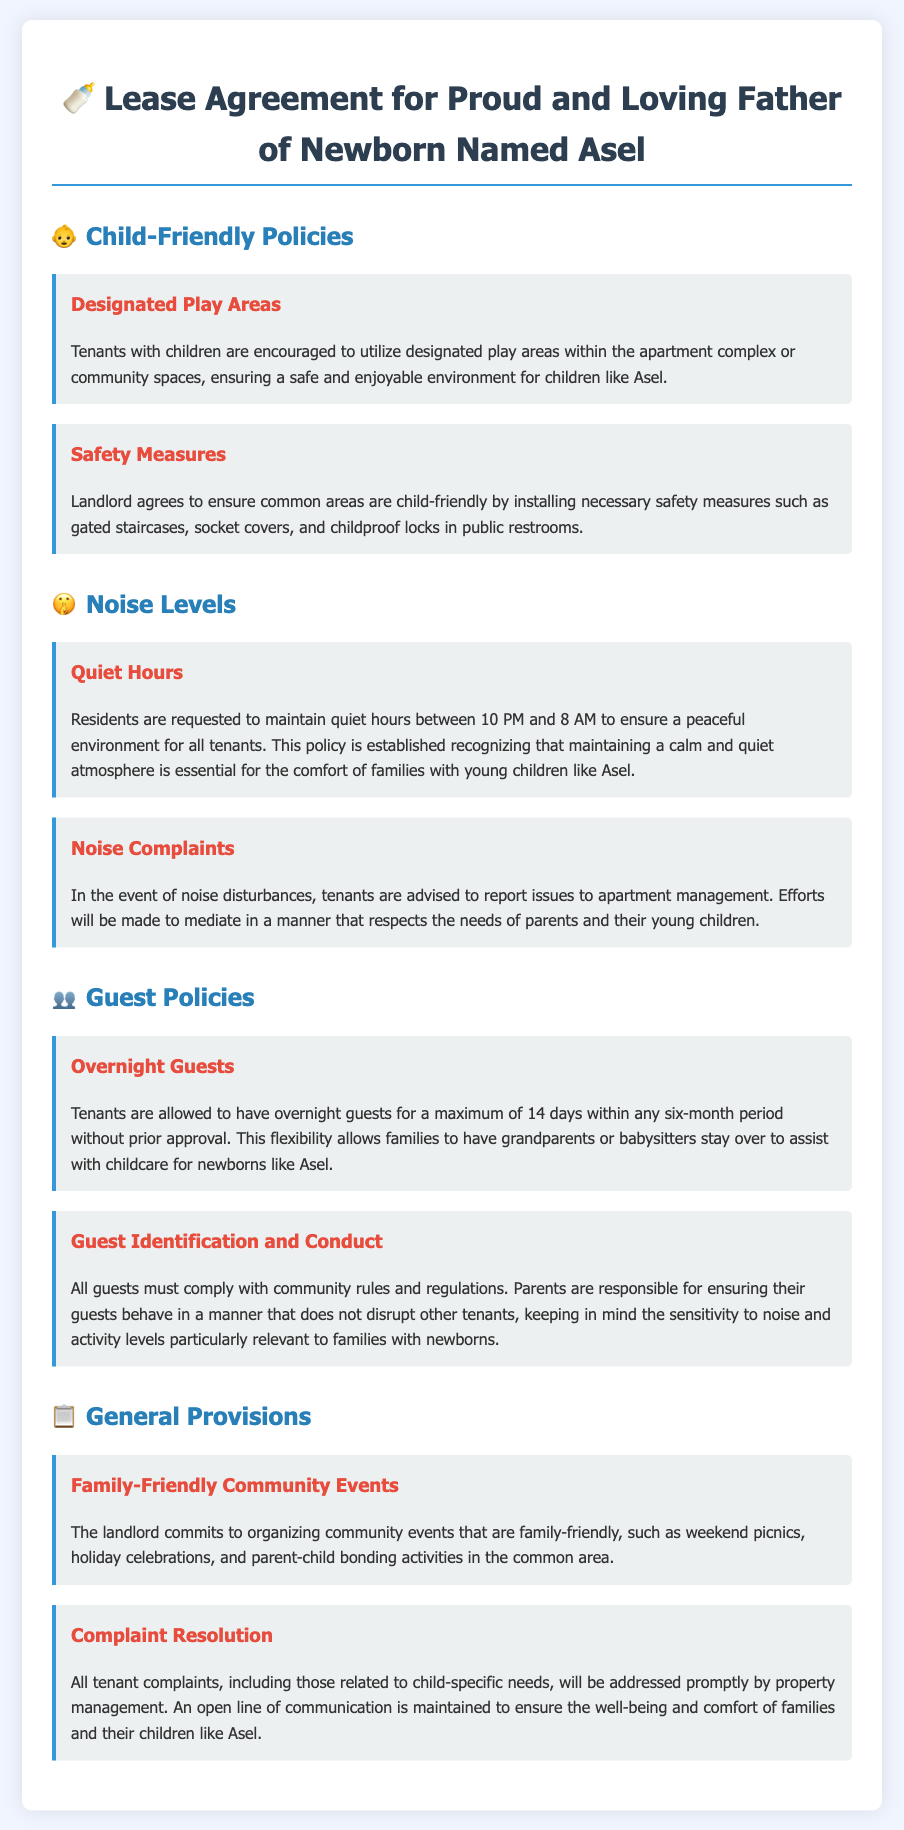What are the designated areas for kids? The document states that tenants with children are encouraged to utilize designated play areas within the apartment complex or community spaces.
Answer: Designated play areas What are the quiet hours? Quiet hours are specified as the time during which residents are requested to maintain silence. The document states quiet hours are between 10 PM and 8 AM.
Answer: 10 PM to 8 AM How many overnight guests are allowed? The document mentions a limit on overnight guests and specifies that tenants can have guests for a maximum of 14 days within any six-month period without prior approval.
Answer: 14 days What type of community events are organized? The landlord commits to organizing family-friendly community events highlighted specifically in the document.
Answer: Family-friendly events Who is responsible for guest conduct? The document indicates that parents are responsible for ensuring their guests behave in a manner that does not disrupt other tenants.
Answer: Parents What measure is mentioned for safety in common areas? The agreement includes safety measures like gated staircases, socket covers, and childproof locks in public restrooms.
Answer: Safety measures How will noise complaints be handled? The document notes that tenants should report noise disturbances to apartment management, which will mediate issues while respecting families' needs.
Answer: Report to management Is there any provision for resolving tenant complaints? Yes, the document states all tenant complaints, including child-specific needs, will be addressed promptly by property management.
Answer: Yes 